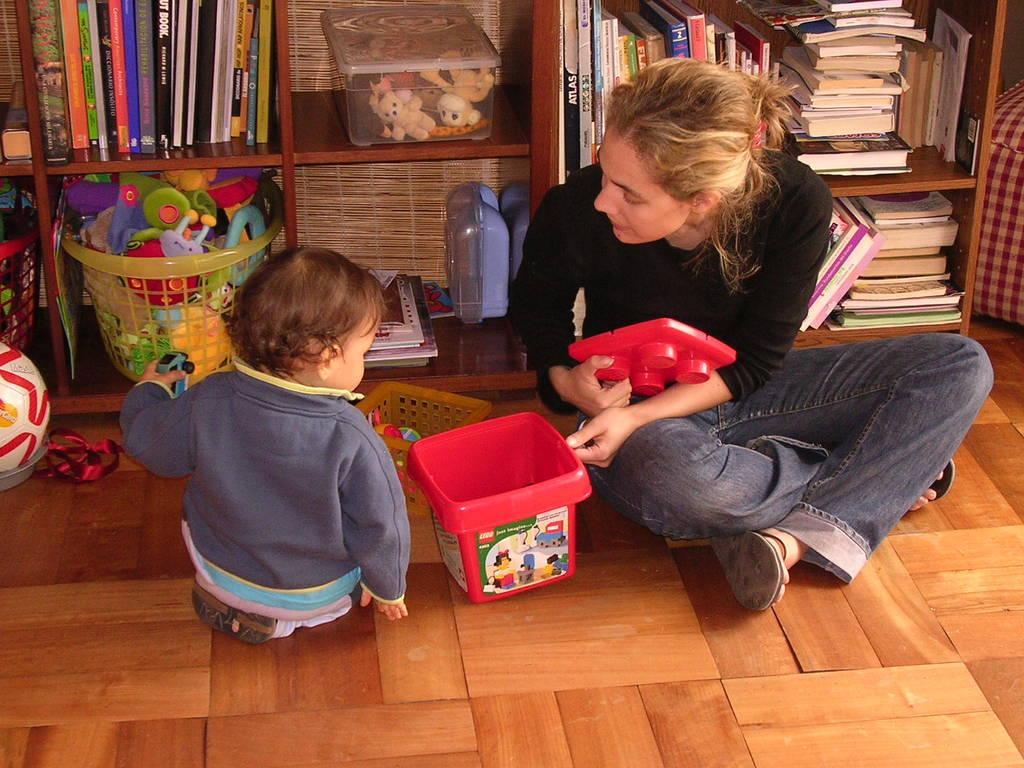Describe this image in one or two sentences. In this image we can see one woman and one child sitting on the floor, there is a wooden shelf in the background, there are few books, toys in a basket, few objects on it. 